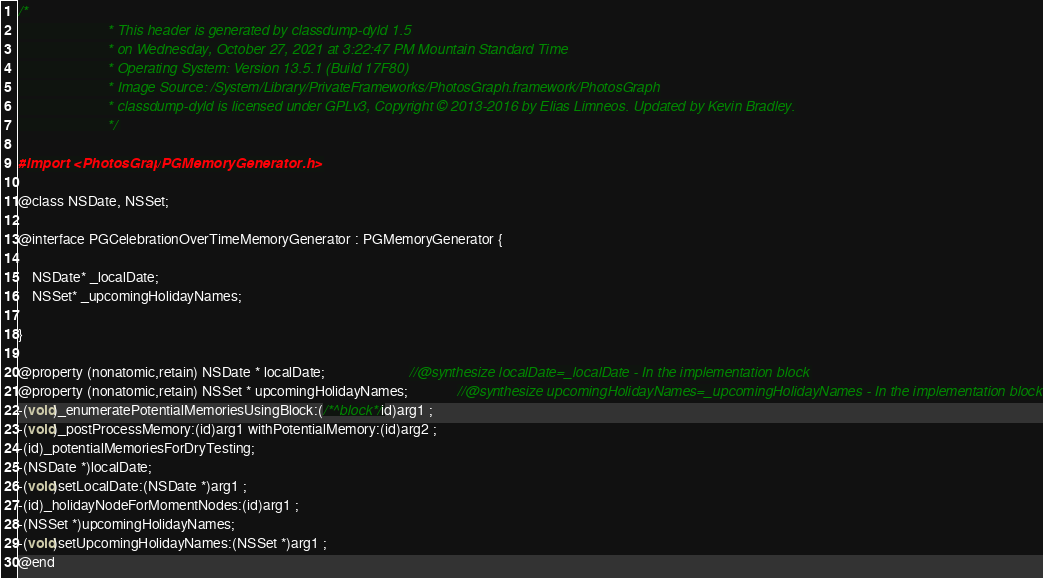<code> <loc_0><loc_0><loc_500><loc_500><_C_>/*
                       * This header is generated by classdump-dyld 1.5
                       * on Wednesday, October 27, 2021 at 3:22:47 PM Mountain Standard Time
                       * Operating System: Version 13.5.1 (Build 17F80)
                       * Image Source: /System/Library/PrivateFrameworks/PhotosGraph.framework/PhotosGraph
                       * classdump-dyld is licensed under GPLv3, Copyright © 2013-2016 by Elias Limneos. Updated by Kevin Bradley.
                       */

#import <PhotosGraph/PGMemoryGenerator.h>

@class NSDate, NSSet;

@interface PGCelebrationOverTimeMemoryGenerator : PGMemoryGenerator {

	NSDate* _localDate;
	NSSet* _upcomingHolidayNames;

}

@property (nonatomic,retain) NSDate * localDate;                        //@synthesize localDate=_localDate - In the implementation block
@property (nonatomic,retain) NSSet * upcomingHolidayNames;              //@synthesize upcomingHolidayNames=_upcomingHolidayNames - In the implementation block
-(void)_enumeratePotentialMemoriesUsingBlock:(/*^block*/id)arg1 ;
-(void)_postProcessMemory:(id)arg1 withPotentialMemory:(id)arg2 ;
-(id)_potentialMemoriesForDryTesting;
-(NSDate *)localDate;
-(void)setLocalDate:(NSDate *)arg1 ;
-(id)_holidayNodeForMomentNodes:(id)arg1 ;
-(NSSet *)upcomingHolidayNames;
-(void)setUpcomingHolidayNames:(NSSet *)arg1 ;
@end

</code> 